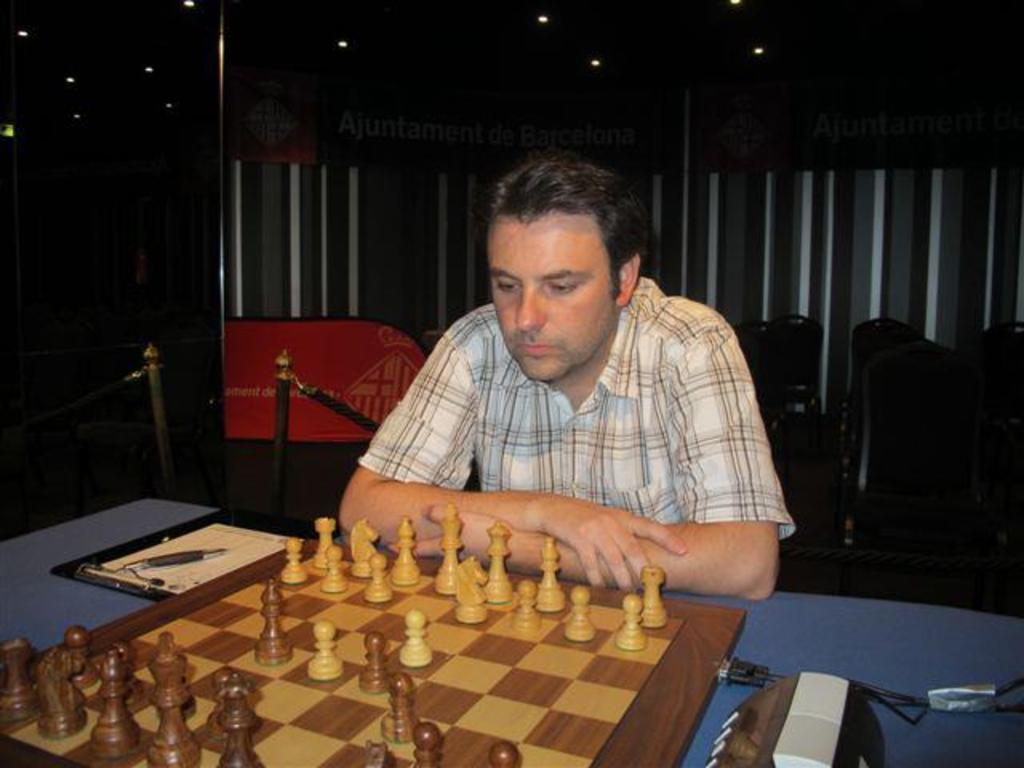Can you describe this image briefly? There is a person sitting. In front of him there is a table. On the table there is chess board with coins, writing pad, paper, pen and some other things. In the back there are poles with ropes, chains and banners. 